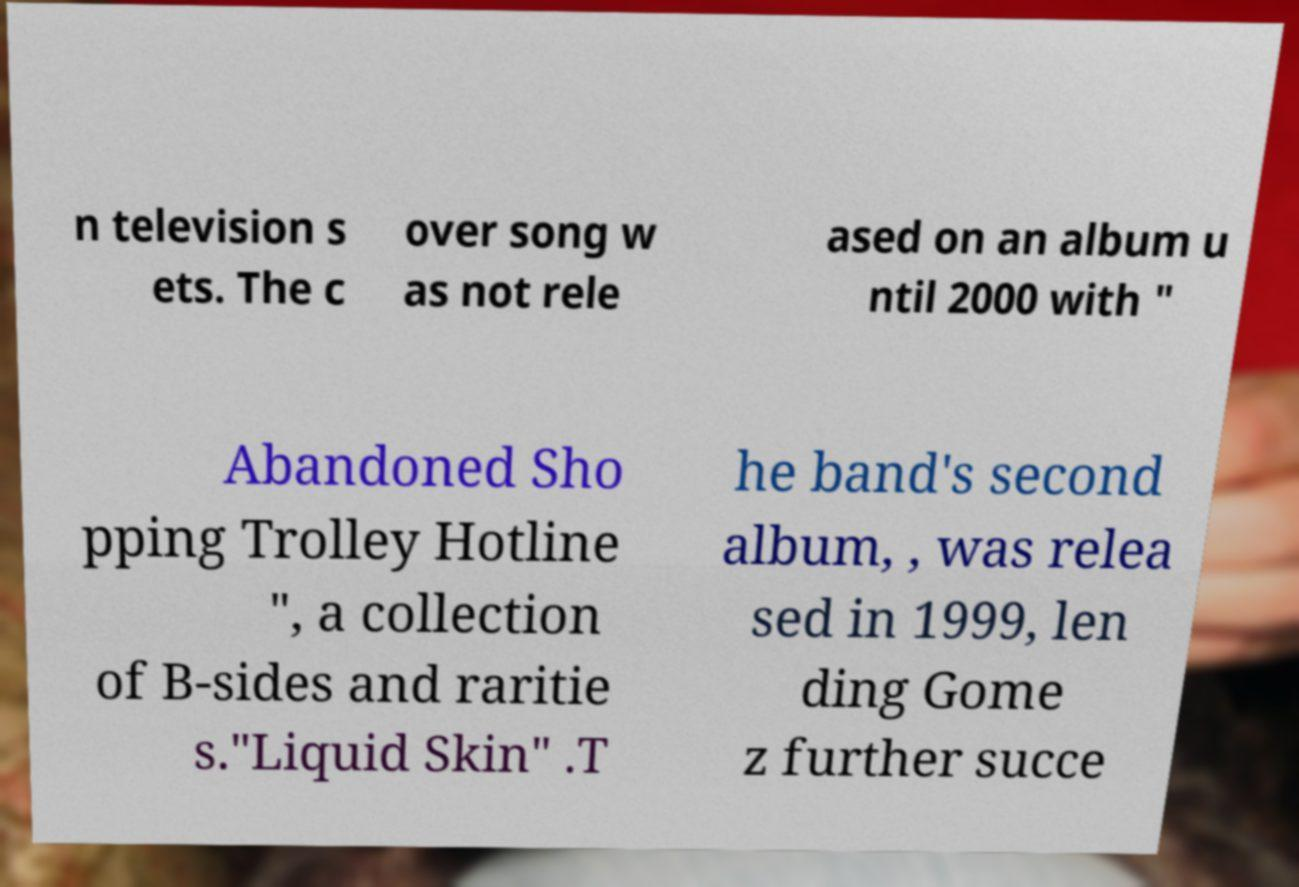There's text embedded in this image that I need extracted. Can you transcribe it verbatim? n television s ets. The c over song w as not rele ased on an album u ntil 2000 with " Abandoned Sho pping Trolley Hotline ", a collection of B-sides and raritie s."Liquid Skin" .T he band's second album, , was relea sed in 1999, len ding Gome z further succe 